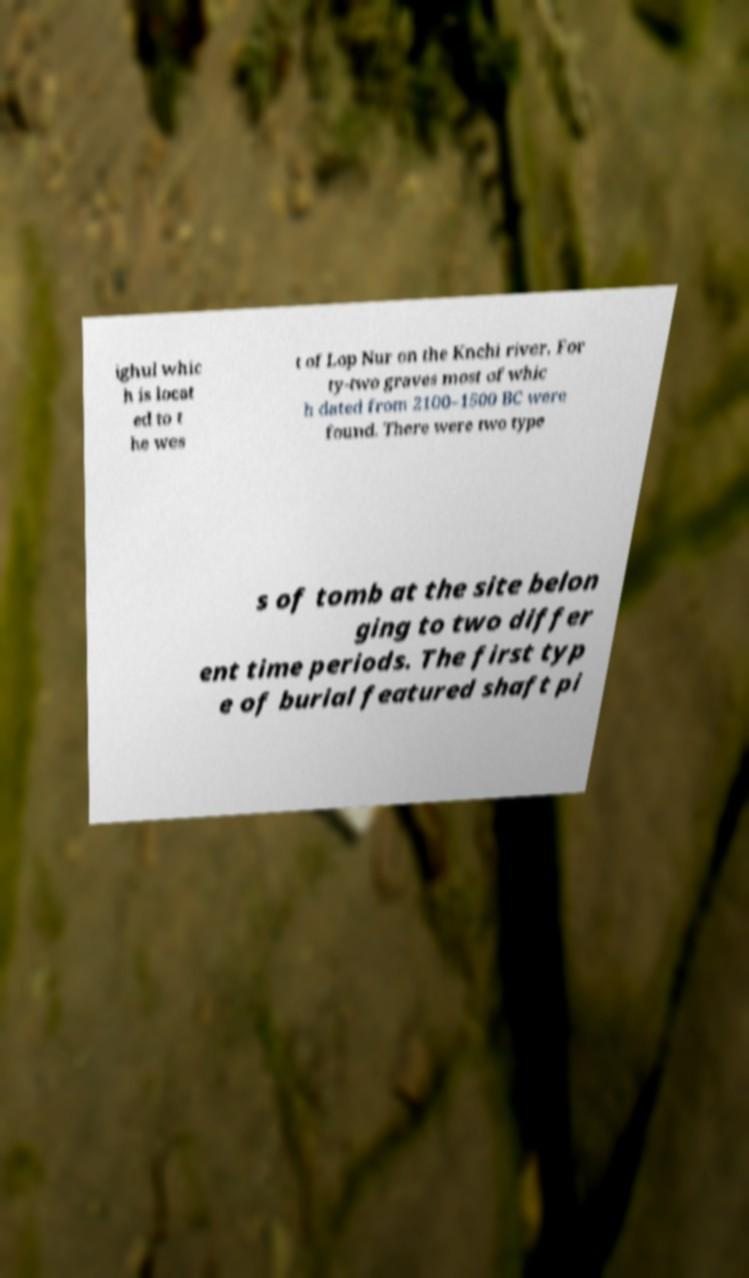For documentation purposes, I need the text within this image transcribed. Could you provide that? ighul whic h is locat ed to t he wes t of Lop Nur on the Knchi river. For ty-two graves most of whic h dated from 2100–1500 BC were found. There were two type s of tomb at the site belon ging to two differ ent time periods. The first typ e of burial featured shaft pi 